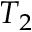Convert formula to latex. <formula><loc_0><loc_0><loc_500><loc_500>T _ { 2 }</formula> 